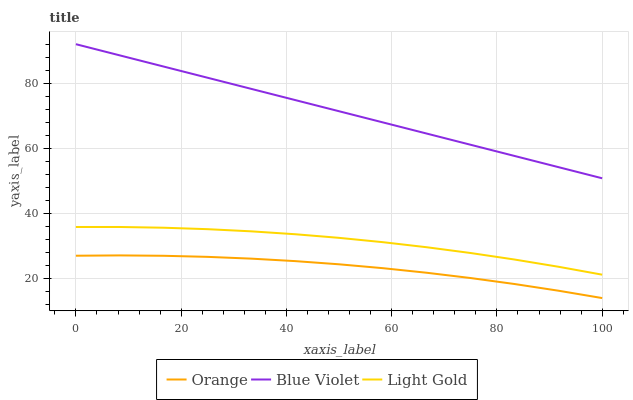Does Orange have the minimum area under the curve?
Answer yes or no. Yes. Does Blue Violet have the maximum area under the curve?
Answer yes or no. Yes. Does Light Gold have the minimum area under the curve?
Answer yes or no. No. Does Light Gold have the maximum area under the curve?
Answer yes or no. No. Is Blue Violet the smoothest?
Answer yes or no. Yes. Is Light Gold the roughest?
Answer yes or no. Yes. Is Light Gold the smoothest?
Answer yes or no. No. Is Blue Violet the roughest?
Answer yes or no. No. Does Orange have the lowest value?
Answer yes or no. Yes. Does Light Gold have the lowest value?
Answer yes or no. No. Does Blue Violet have the highest value?
Answer yes or no. Yes. Does Light Gold have the highest value?
Answer yes or no. No. Is Orange less than Blue Violet?
Answer yes or no. Yes. Is Blue Violet greater than Orange?
Answer yes or no. Yes. Does Orange intersect Blue Violet?
Answer yes or no. No. 